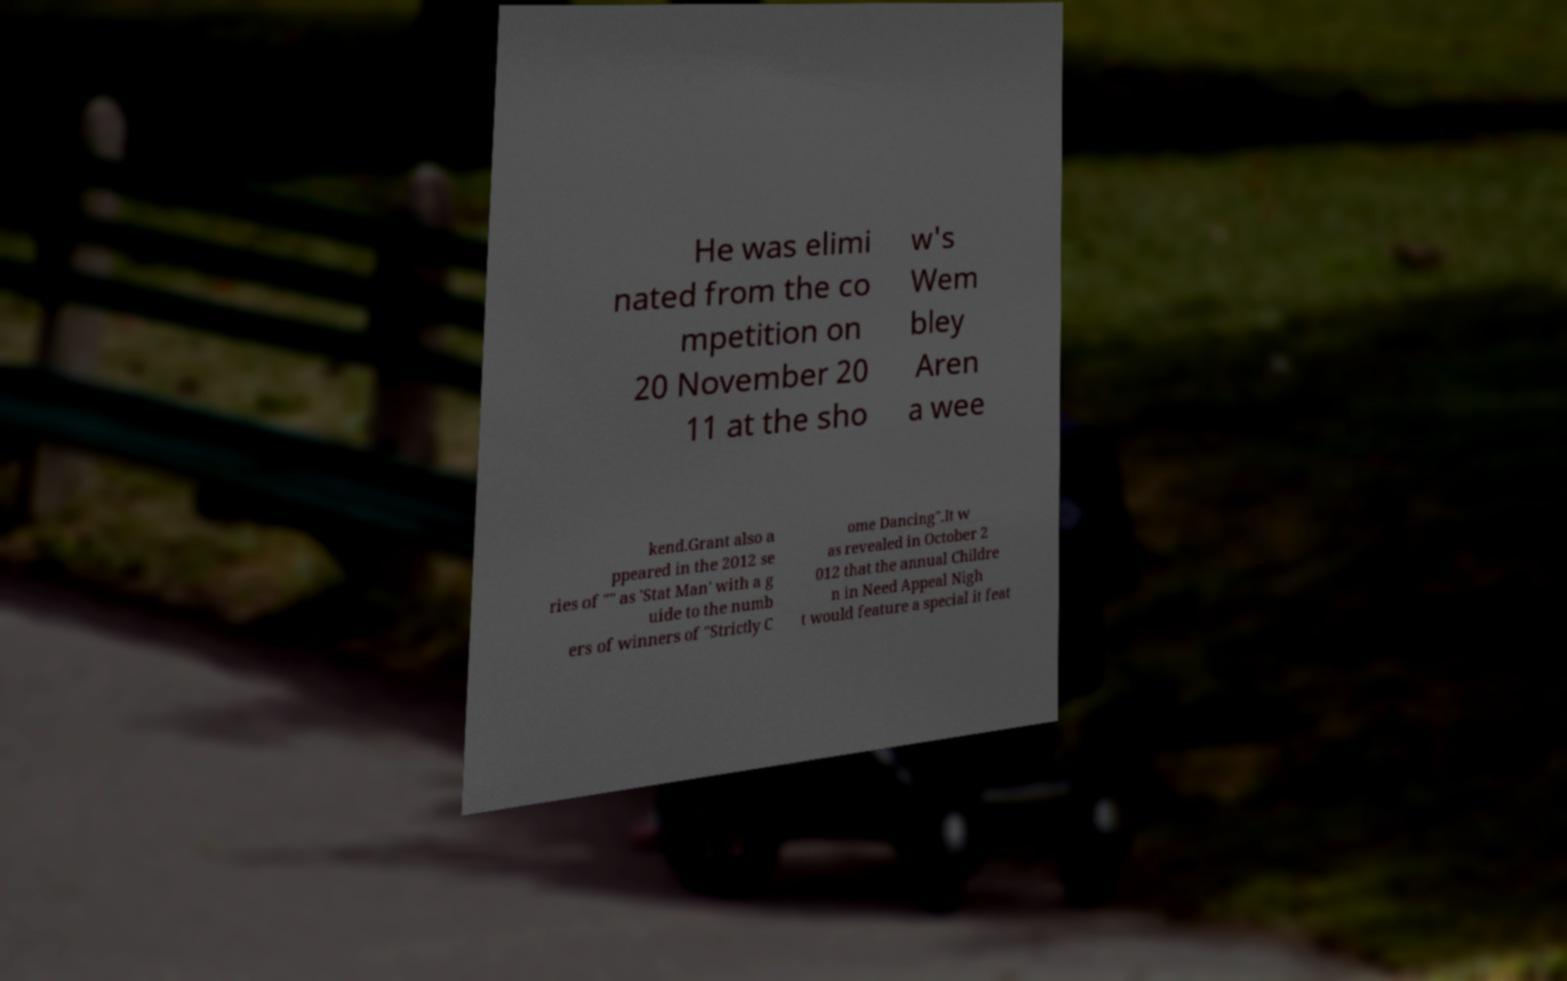Can you accurately transcribe the text from the provided image for me? He was elimi nated from the co mpetition on 20 November 20 11 at the sho w's Wem bley Aren a wee kend.Grant also a ppeared in the 2012 se ries of "" as 'Stat Man' with a g uide to the numb ers of winners of "Strictly C ome Dancing".It w as revealed in October 2 012 that the annual Childre n in Need Appeal Nigh t would feature a special it feat 